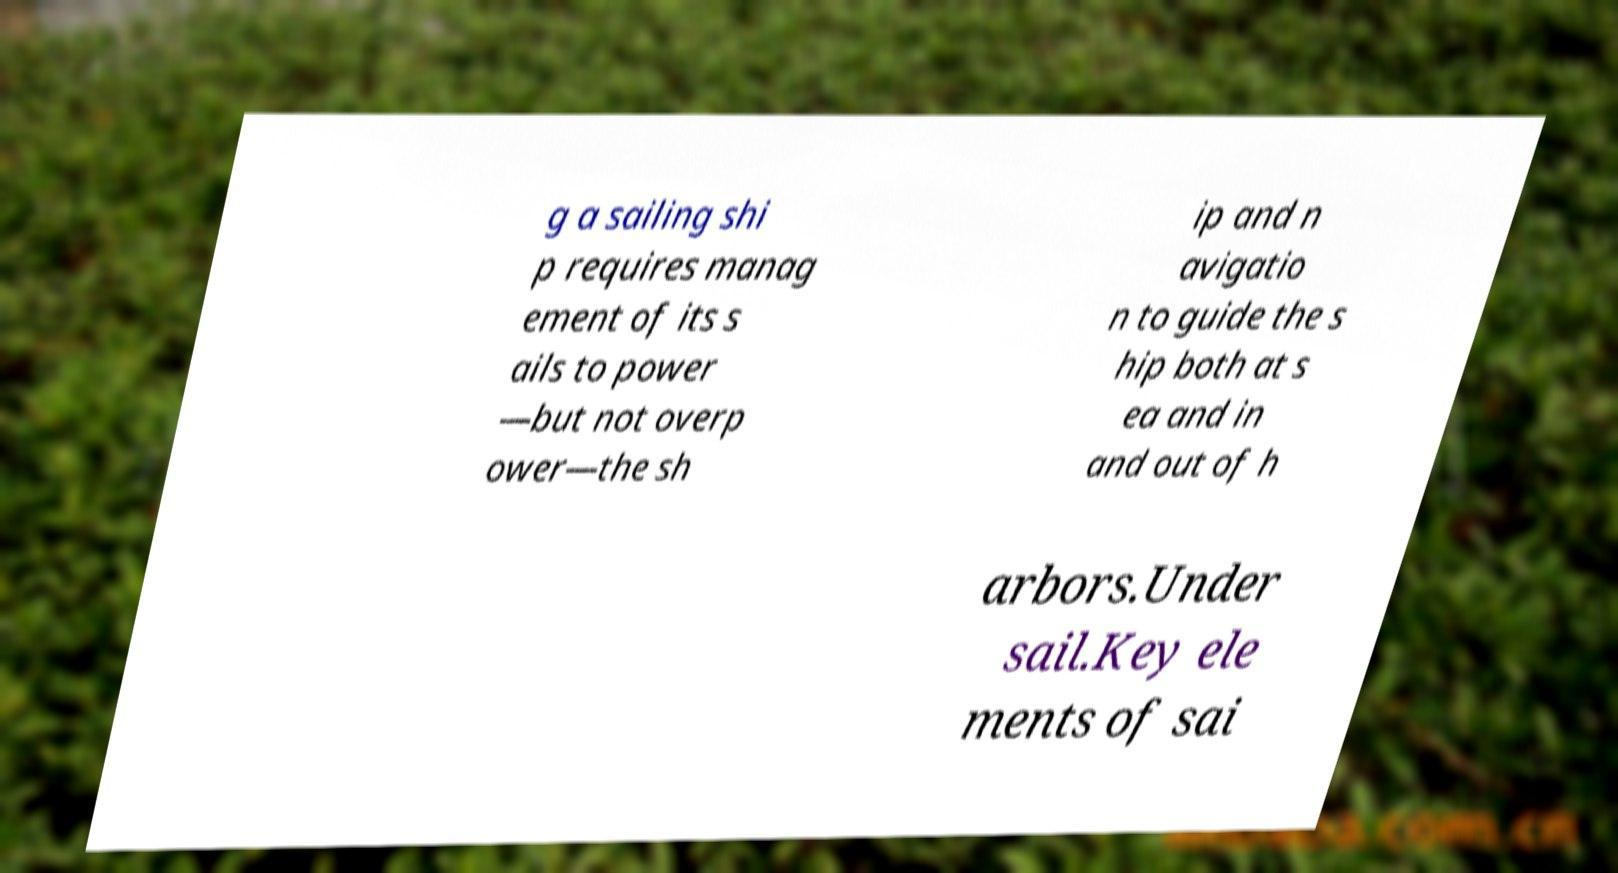Could you extract and type out the text from this image? g a sailing shi p requires manag ement of its s ails to power —but not overp ower—the sh ip and n avigatio n to guide the s hip both at s ea and in and out of h arbors.Under sail.Key ele ments of sai 